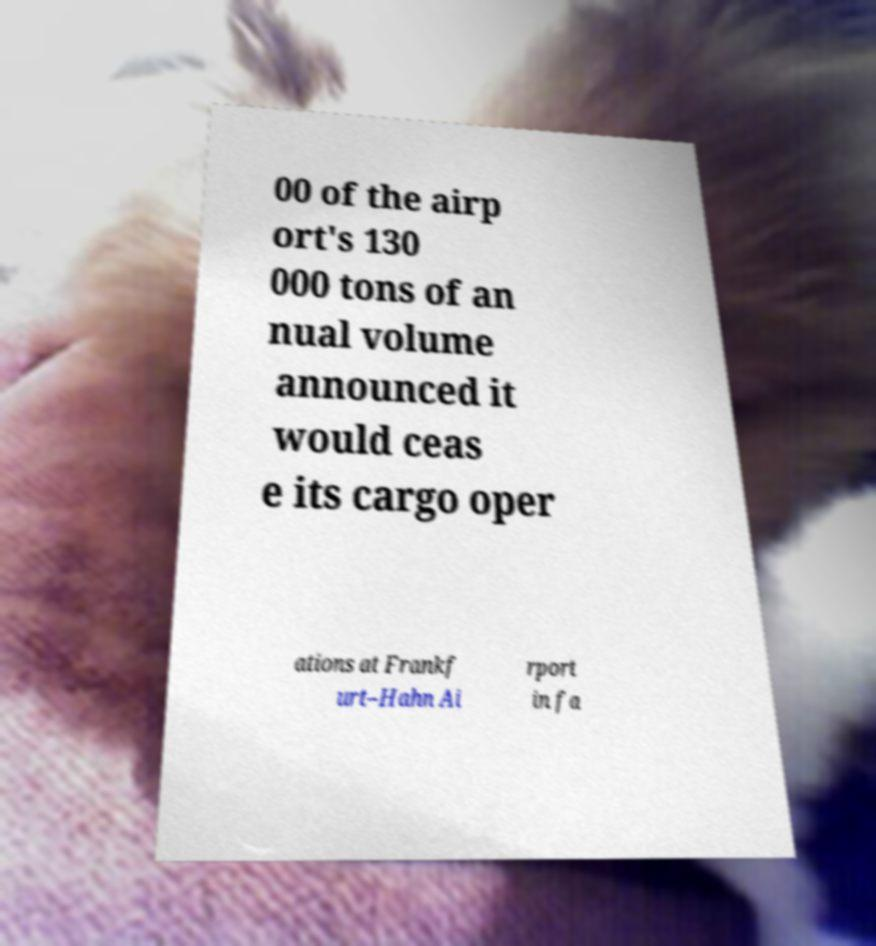Please read and relay the text visible in this image. What does it say? 00 of the airp ort's 130 000 tons of an nual volume announced it would ceas e its cargo oper ations at Frankf urt–Hahn Ai rport in fa 